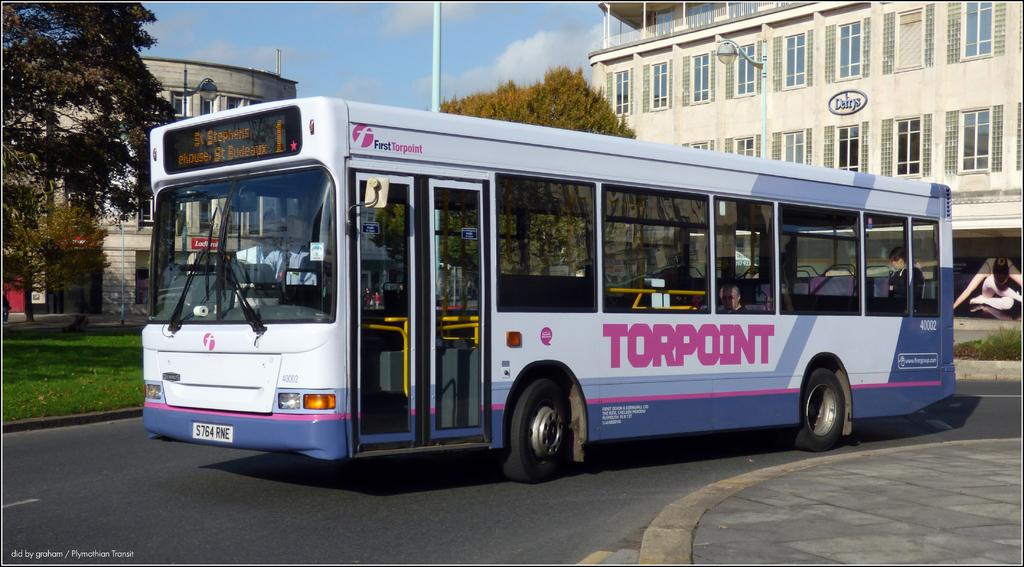<image>
Write a terse but informative summary of the picture. St. Stephens, ehouse, St. Budeaux is displayed on the front of this Torpoint public bus. 